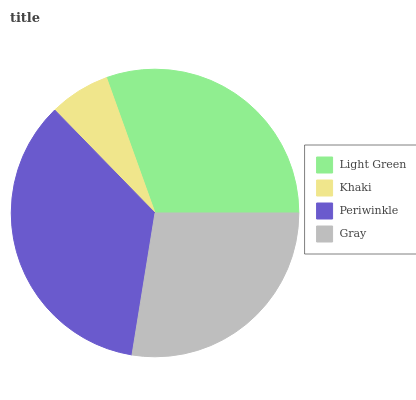Is Khaki the minimum?
Answer yes or no. Yes. Is Periwinkle the maximum?
Answer yes or no. Yes. Is Periwinkle the minimum?
Answer yes or no. No. Is Khaki the maximum?
Answer yes or no. No. Is Periwinkle greater than Khaki?
Answer yes or no. Yes. Is Khaki less than Periwinkle?
Answer yes or no. Yes. Is Khaki greater than Periwinkle?
Answer yes or no. No. Is Periwinkle less than Khaki?
Answer yes or no. No. Is Light Green the high median?
Answer yes or no. Yes. Is Gray the low median?
Answer yes or no. Yes. Is Periwinkle the high median?
Answer yes or no. No. Is Light Green the low median?
Answer yes or no. No. 